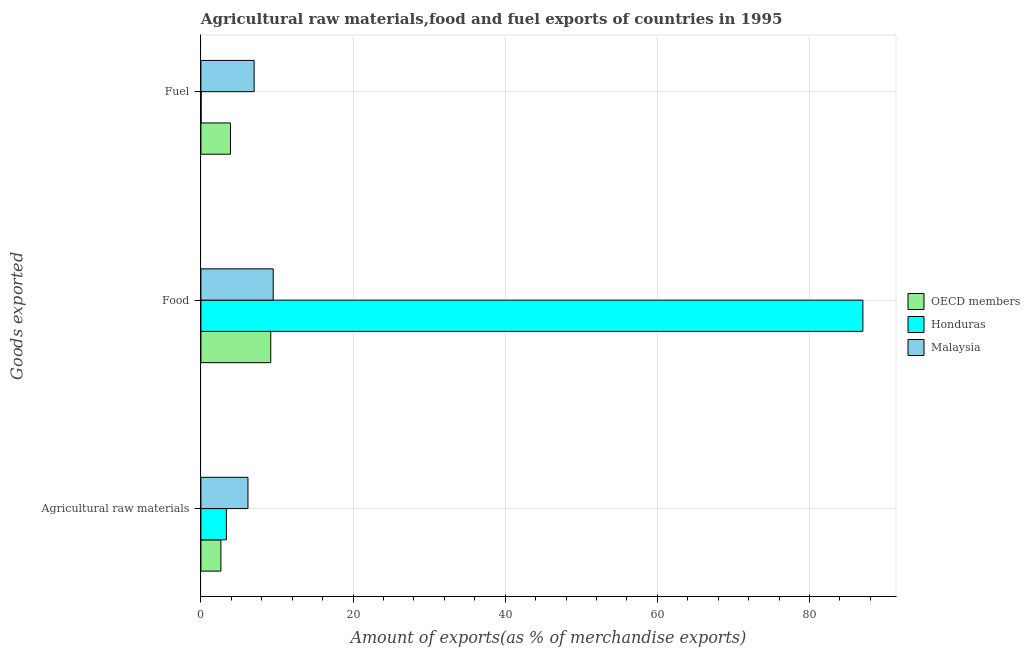Are the number of bars per tick equal to the number of legend labels?
Make the answer very short. Yes. Are the number of bars on each tick of the Y-axis equal?
Your answer should be very brief. Yes. How many bars are there on the 2nd tick from the top?
Your answer should be very brief. 3. What is the label of the 3rd group of bars from the top?
Keep it short and to the point. Agricultural raw materials. What is the percentage of fuel exports in Honduras?
Your response must be concise. 0.02. Across all countries, what is the maximum percentage of fuel exports?
Give a very brief answer. 7. Across all countries, what is the minimum percentage of fuel exports?
Give a very brief answer. 0.02. In which country was the percentage of food exports maximum?
Provide a short and direct response. Honduras. In which country was the percentage of fuel exports minimum?
Keep it short and to the point. Honduras. What is the total percentage of raw materials exports in the graph?
Make the answer very short. 12.16. What is the difference between the percentage of raw materials exports in Honduras and that in OECD members?
Offer a terse response. 0.72. What is the difference between the percentage of food exports in Honduras and the percentage of raw materials exports in OECD members?
Provide a short and direct response. 84.39. What is the average percentage of raw materials exports per country?
Make the answer very short. 4.05. What is the difference between the percentage of fuel exports and percentage of food exports in Honduras?
Your answer should be very brief. -87. What is the ratio of the percentage of fuel exports in OECD members to that in Malaysia?
Provide a succinct answer. 0.56. Is the percentage of food exports in Honduras less than that in Malaysia?
Give a very brief answer. No. What is the difference between the highest and the second highest percentage of food exports?
Your answer should be very brief. 77.51. What is the difference between the highest and the lowest percentage of fuel exports?
Your answer should be very brief. 6.98. Is the sum of the percentage of raw materials exports in Malaysia and OECD members greater than the maximum percentage of fuel exports across all countries?
Your response must be concise. Yes. What does the 2nd bar from the top in Fuel represents?
Ensure brevity in your answer.  Honduras. What does the 2nd bar from the bottom in Food represents?
Your answer should be compact. Honduras. Are the values on the major ticks of X-axis written in scientific E-notation?
Your answer should be very brief. No. Does the graph contain any zero values?
Your answer should be very brief. No. Where does the legend appear in the graph?
Give a very brief answer. Center right. How many legend labels are there?
Keep it short and to the point. 3. What is the title of the graph?
Offer a terse response. Agricultural raw materials,food and fuel exports of countries in 1995. Does "Syrian Arab Republic" appear as one of the legend labels in the graph?
Your answer should be very brief. No. What is the label or title of the X-axis?
Your answer should be very brief. Amount of exports(as % of merchandise exports). What is the label or title of the Y-axis?
Ensure brevity in your answer.  Goods exported. What is the Amount of exports(as % of merchandise exports) of OECD members in Agricultural raw materials?
Offer a very short reply. 2.63. What is the Amount of exports(as % of merchandise exports) in Honduras in Agricultural raw materials?
Your answer should be compact. 3.35. What is the Amount of exports(as % of merchandise exports) of Malaysia in Agricultural raw materials?
Your response must be concise. 6.18. What is the Amount of exports(as % of merchandise exports) of OECD members in Food?
Your response must be concise. 9.18. What is the Amount of exports(as % of merchandise exports) of Honduras in Food?
Make the answer very short. 87.02. What is the Amount of exports(as % of merchandise exports) in Malaysia in Food?
Offer a very short reply. 9.5. What is the Amount of exports(as % of merchandise exports) of OECD members in Fuel?
Keep it short and to the point. 3.89. What is the Amount of exports(as % of merchandise exports) in Honduras in Fuel?
Offer a very short reply. 0.02. What is the Amount of exports(as % of merchandise exports) of Malaysia in Fuel?
Your response must be concise. 7. Across all Goods exported, what is the maximum Amount of exports(as % of merchandise exports) in OECD members?
Ensure brevity in your answer.  9.18. Across all Goods exported, what is the maximum Amount of exports(as % of merchandise exports) in Honduras?
Keep it short and to the point. 87.02. Across all Goods exported, what is the maximum Amount of exports(as % of merchandise exports) in Malaysia?
Give a very brief answer. 9.5. Across all Goods exported, what is the minimum Amount of exports(as % of merchandise exports) of OECD members?
Ensure brevity in your answer.  2.63. Across all Goods exported, what is the minimum Amount of exports(as % of merchandise exports) of Honduras?
Provide a succinct answer. 0.02. Across all Goods exported, what is the minimum Amount of exports(as % of merchandise exports) in Malaysia?
Provide a short and direct response. 6.18. What is the total Amount of exports(as % of merchandise exports) in OECD members in the graph?
Provide a short and direct response. 15.69. What is the total Amount of exports(as % of merchandise exports) of Honduras in the graph?
Your response must be concise. 90.39. What is the total Amount of exports(as % of merchandise exports) of Malaysia in the graph?
Make the answer very short. 22.68. What is the difference between the Amount of exports(as % of merchandise exports) of OECD members in Agricultural raw materials and that in Food?
Keep it short and to the point. -6.55. What is the difference between the Amount of exports(as % of merchandise exports) in Honduras in Agricultural raw materials and that in Food?
Your answer should be very brief. -83.67. What is the difference between the Amount of exports(as % of merchandise exports) in Malaysia in Agricultural raw materials and that in Food?
Keep it short and to the point. -3.32. What is the difference between the Amount of exports(as % of merchandise exports) of OECD members in Agricultural raw materials and that in Fuel?
Ensure brevity in your answer.  -1.26. What is the difference between the Amount of exports(as % of merchandise exports) of Honduras in Agricultural raw materials and that in Fuel?
Ensure brevity in your answer.  3.33. What is the difference between the Amount of exports(as % of merchandise exports) in Malaysia in Agricultural raw materials and that in Fuel?
Offer a very short reply. -0.81. What is the difference between the Amount of exports(as % of merchandise exports) of OECD members in Food and that in Fuel?
Your answer should be compact. 5.29. What is the difference between the Amount of exports(as % of merchandise exports) in Honduras in Food and that in Fuel?
Ensure brevity in your answer.  87. What is the difference between the Amount of exports(as % of merchandise exports) of Malaysia in Food and that in Fuel?
Give a very brief answer. 2.51. What is the difference between the Amount of exports(as % of merchandise exports) of OECD members in Agricultural raw materials and the Amount of exports(as % of merchandise exports) of Honduras in Food?
Provide a short and direct response. -84.39. What is the difference between the Amount of exports(as % of merchandise exports) in OECD members in Agricultural raw materials and the Amount of exports(as % of merchandise exports) in Malaysia in Food?
Offer a very short reply. -6.88. What is the difference between the Amount of exports(as % of merchandise exports) in Honduras in Agricultural raw materials and the Amount of exports(as % of merchandise exports) in Malaysia in Food?
Provide a short and direct response. -6.15. What is the difference between the Amount of exports(as % of merchandise exports) in OECD members in Agricultural raw materials and the Amount of exports(as % of merchandise exports) in Honduras in Fuel?
Your answer should be very brief. 2.6. What is the difference between the Amount of exports(as % of merchandise exports) in OECD members in Agricultural raw materials and the Amount of exports(as % of merchandise exports) in Malaysia in Fuel?
Keep it short and to the point. -4.37. What is the difference between the Amount of exports(as % of merchandise exports) of Honduras in Agricultural raw materials and the Amount of exports(as % of merchandise exports) of Malaysia in Fuel?
Your response must be concise. -3.65. What is the difference between the Amount of exports(as % of merchandise exports) in OECD members in Food and the Amount of exports(as % of merchandise exports) in Honduras in Fuel?
Keep it short and to the point. 9.16. What is the difference between the Amount of exports(as % of merchandise exports) in OECD members in Food and the Amount of exports(as % of merchandise exports) in Malaysia in Fuel?
Your answer should be compact. 2.18. What is the difference between the Amount of exports(as % of merchandise exports) in Honduras in Food and the Amount of exports(as % of merchandise exports) in Malaysia in Fuel?
Give a very brief answer. 80.02. What is the average Amount of exports(as % of merchandise exports) in OECD members per Goods exported?
Your answer should be compact. 5.23. What is the average Amount of exports(as % of merchandise exports) of Honduras per Goods exported?
Your answer should be compact. 30.13. What is the average Amount of exports(as % of merchandise exports) in Malaysia per Goods exported?
Keep it short and to the point. 7.56. What is the difference between the Amount of exports(as % of merchandise exports) in OECD members and Amount of exports(as % of merchandise exports) in Honduras in Agricultural raw materials?
Give a very brief answer. -0.72. What is the difference between the Amount of exports(as % of merchandise exports) of OECD members and Amount of exports(as % of merchandise exports) of Malaysia in Agricultural raw materials?
Ensure brevity in your answer.  -3.56. What is the difference between the Amount of exports(as % of merchandise exports) of Honduras and Amount of exports(as % of merchandise exports) of Malaysia in Agricultural raw materials?
Provide a succinct answer. -2.84. What is the difference between the Amount of exports(as % of merchandise exports) in OECD members and Amount of exports(as % of merchandise exports) in Honduras in Food?
Make the answer very short. -77.84. What is the difference between the Amount of exports(as % of merchandise exports) in OECD members and Amount of exports(as % of merchandise exports) in Malaysia in Food?
Give a very brief answer. -0.32. What is the difference between the Amount of exports(as % of merchandise exports) of Honduras and Amount of exports(as % of merchandise exports) of Malaysia in Food?
Give a very brief answer. 77.51. What is the difference between the Amount of exports(as % of merchandise exports) of OECD members and Amount of exports(as % of merchandise exports) of Honduras in Fuel?
Provide a succinct answer. 3.86. What is the difference between the Amount of exports(as % of merchandise exports) of OECD members and Amount of exports(as % of merchandise exports) of Malaysia in Fuel?
Make the answer very short. -3.11. What is the difference between the Amount of exports(as % of merchandise exports) in Honduras and Amount of exports(as % of merchandise exports) in Malaysia in Fuel?
Offer a very short reply. -6.98. What is the ratio of the Amount of exports(as % of merchandise exports) in OECD members in Agricultural raw materials to that in Food?
Offer a very short reply. 0.29. What is the ratio of the Amount of exports(as % of merchandise exports) in Honduras in Agricultural raw materials to that in Food?
Make the answer very short. 0.04. What is the ratio of the Amount of exports(as % of merchandise exports) in Malaysia in Agricultural raw materials to that in Food?
Ensure brevity in your answer.  0.65. What is the ratio of the Amount of exports(as % of merchandise exports) in OECD members in Agricultural raw materials to that in Fuel?
Offer a very short reply. 0.68. What is the ratio of the Amount of exports(as % of merchandise exports) in Honduras in Agricultural raw materials to that in Fuel?
Offer a very short reply. 159.3. What is the ratio of the Amount of exports(as % of merchandise exports) of Malaysia in Agricultural raw materials to that in Fuel?
Make the answer very short. 0.88. What is the ratio of the Amount of exports(as % of merchandise exports) of OECD members in Food to that in Fuel?
Your answer should be compact. 2.36. What is the ratio of the Amount of exports(as % of merchandise exports) in Honduras in Food to that in Fuel?
Keep it short and to the point. 4139.42. What is the ratio of the Amount of exports(as % of merchandise exports) of Malaysia in Food to that in Fuel?
Provide a short and direct response. 1.36. What is the difference between the highest and the second highest Amount of exports(as % of merchandise exports) in OECD members?
Keep it short and to the point. 5.29. What is the difference between the highest and the second highest Amount of exports(as % of merchandise exports) in Honduras?
Your answer should be compact. 83.67. What is the difference between the highest and the second highest Amount of exports(as % of merchandise exports) of Malaysia?
Provide a short and direct response. 2.51. What is the difference between the highest and the lowest Amount of exports(as % of merchandise exports) of OECD members?
Offer a very short reply. 6.55. What is the difference between the highest and the lowest Amount of exports(as % of merchandise exports) of Honduras?
Ensure brevity in your answer.  87. What is the difference between the highest and the lowest Amount of exports(as % of merchandise exports) in Malaysia?
Give a very brief answer. 3.32. 